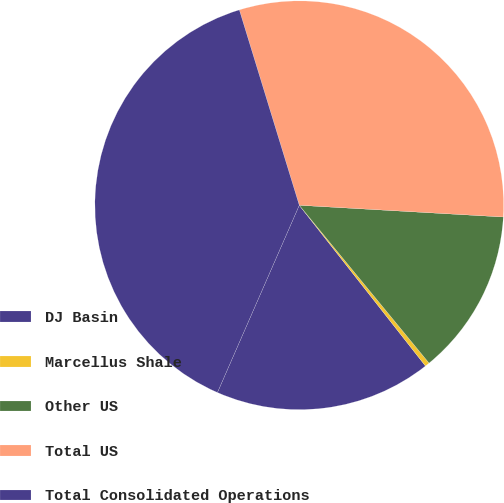Convert chart. <chart><loc_0><loc_0><loc_500><loc_500><pie_chart><fcel>DJ Basin<fcel>Marcellus Shale<fcel>Other US<fcel>Total US<fcel>Total Consolidated Operations<nl><fcel>17.15%<fcel>0.36%<fcel>13.13%<fcel>30.65%<fcel>38.7%<nl></chart> 